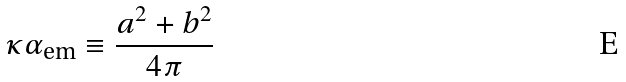Convert formula to latex. <formula><loc_0><loc_0><loc_500><loc_500>\kappa \alpha _ { \text {em} } \equiv \frac { a ^ { 2 } + b ^ { 2 } } { 4 \pi }</formula> 